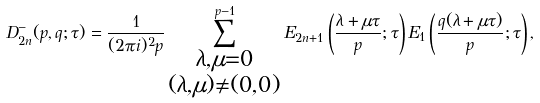<formula> <loc_0><loc_0><loc_500><loc_500>D _ { 2 n } ^ { - } ( p , q ; \tau ) = \frac { 1 } { ( 2 \pi i ) ^ { 2 } p } \sum _ { \substack { \lambda , \mu = 0 \\ ( \lambda , \mu ) \ne ( 0 , 0 ) } } ^ { p - 1 } E _ { 2 n + 1 } \left ( \frac { \lambda + \mu \tau } { p } ; \tau \right ) E _ { 1 } \left ( \frac { q ( \lambda + \mu \tau ) } { p } ; \tau \right ) ,</formula> 